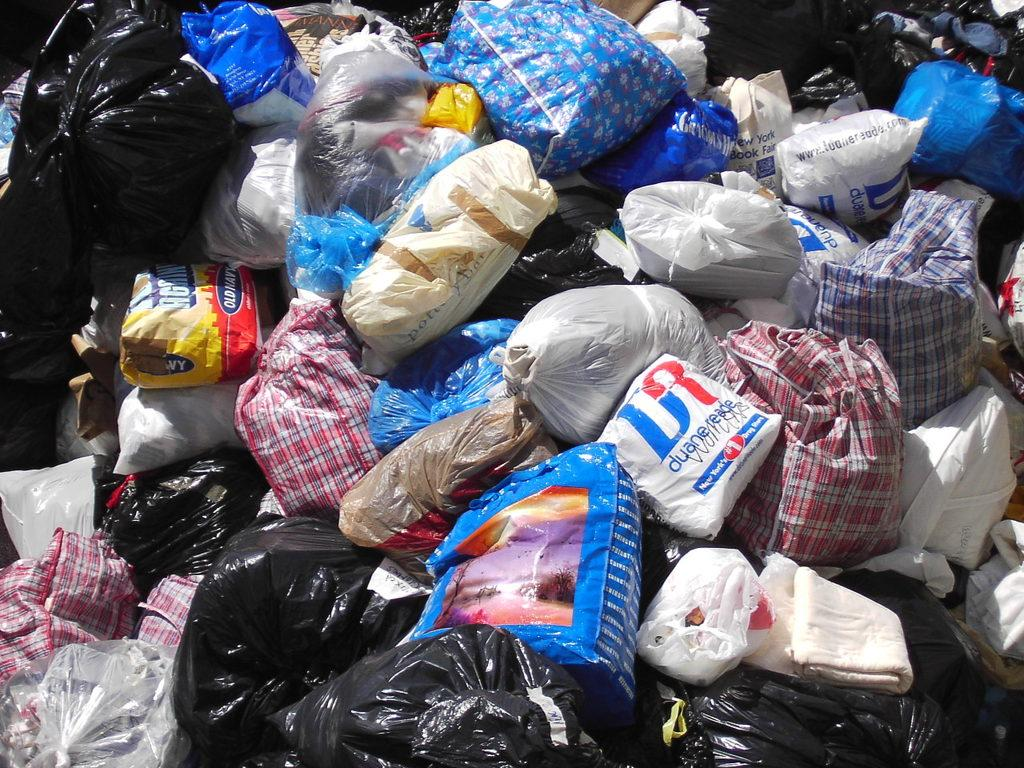What objects are on the ground in the image? There are garbage bags on the ground in the image. What time of day is the grandfather attacking the garbage bags in the image? There is no grandfather or attack present in the image; it only shows garbage bags on the ground. 